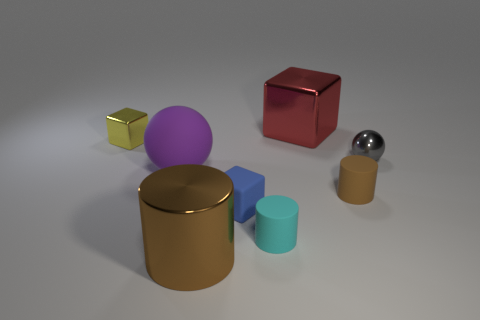Add 2 brown matte cubes. How many objects exist? 10 Subtract all blocks. How many objects are left? 5 Subtract 1 cyan cylinders. How many objects are left? 7 Subtract all tiny matte objects. Subtract all large blue rubber cylinders. How many objects are left? 5 Add 3 red metal blocks. How many red metal blocks are left? 4 Add 1 tiny gray things. How many tiny gray things exist? 2 